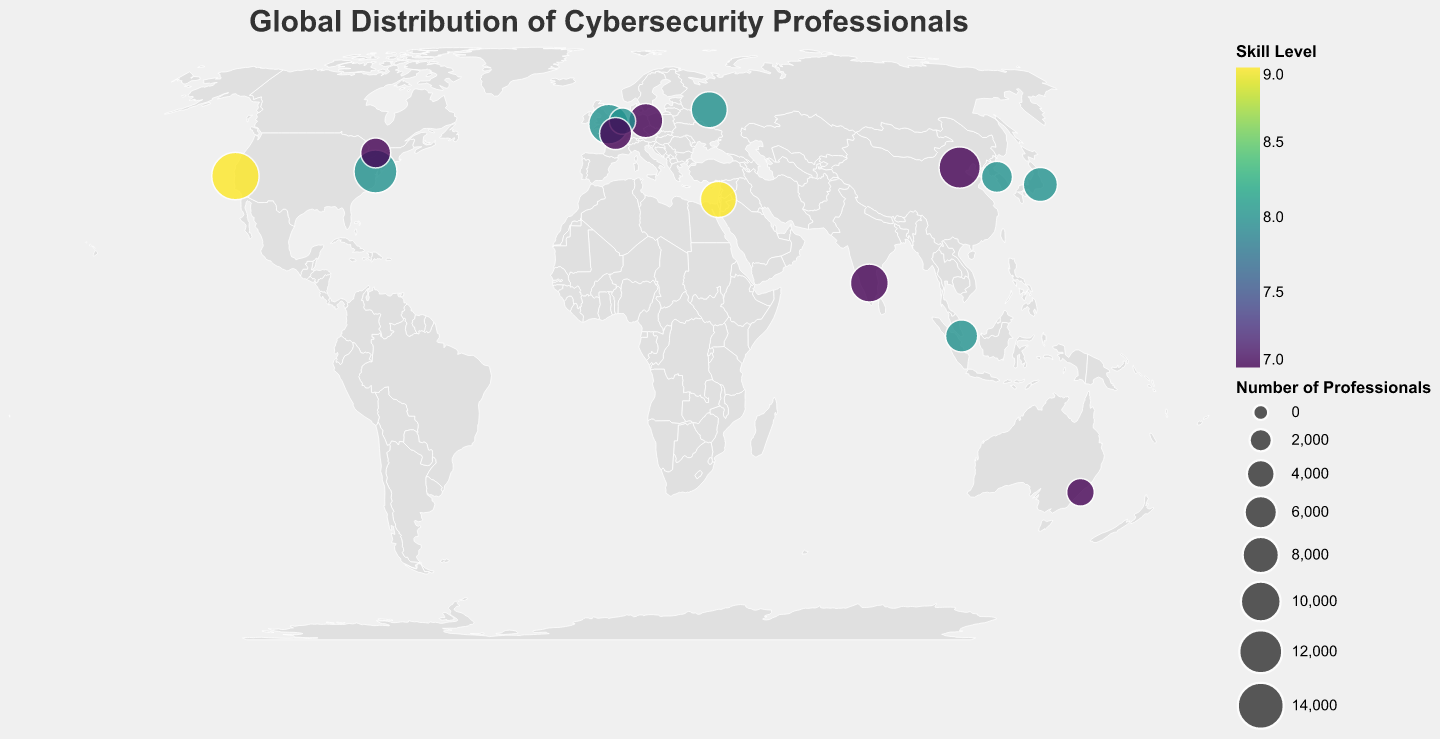What is the title of the plot? The title of the plot is located at the top and is usually a summary of the entire figure. Here, the title is "Global Distribution of Cybersecurity Professionals".
Answer: Global Distribution of Cybersecurity Professionals Which city in the United States has the highest number of cybersecurity professionals? The chart includes data points for San Francisco and Washington D.C. in the United States. By comparing these, San Francisco has 15,000 professionals, which is higher than Washington D.C.'s 12,000 professionals.
Answer: San Francisco Which country has the highest average skill level of cybersecurity professionals? To find this, examine each country's cities and calculate the average skill level: 
- United States: (9+8)/2 = 8.5
- Israel: 9
- United Kingdom: 8
- Singapore: 8
- Germany: 7
- Canada: 7
- India: 7
- Japan: 8
- Australia: 7
- Netherlands: 8
- South Korea: 8
- France: 7
- Russia: 8
- China: 7
Israel has the highest average skill level at 9.
Answer: Israel What is the combined number of cybersecurity professionals in Berlin and Tokyo? The number of professionals in Berlin is 7,000 and in Tokyo is 7,000. Adding these together: 7,000 + 7,000 = 14,000.
Answer: 14,000 Identify the city with the highest skill level and describe its location. The highest skill level shown is 9, and it can be found in both San Francisco (United States) and Tel Aviv (Israel). San Francisco is located at longitude -122.4194 and latitude 37.7749 in the United States. Tel Aviv is located at longitude 34.7818 and latitude 32.0853 in Israel.
Answer: San Francisco and Tel Aviv Which city has more cybersecurity professionals: Beijing or Bangalore? By comparing the data points for the two cities, Beijing has 11,000 professionals and Bangalore has 9,000 professionals. Beijing has more professionals.
Answer: Beijing How does the skill level in Paris compare to the one in Berlin? According to the data, Paris has a skill level of 7 and Berlin has a skill level of 7 as well. Their skill levels are equal.
Answer: Equal What is the color used to represent the highest skill level in the plot? The highest skill level in the dataset is 9, represented by two circles, one for San Francisco and Tel Aviv. According to the legend and color scheme used (viridis), the highest skill level is typically represented by a dark shade of purple.
Answer: Dark purple What is the total number of cybersecurity professionals in Asia according to the plot? Summing the number of professionals from Asian cities:
- Tel Aviv: 8,000
- Singapore: 6,000
- Bangalore: 9,000
- Tokyo: 7,000
- Seoul: 5,500
- Beijing: 11,000
Total: 8,000 + 6,000 + 9,000 + 7,000 + 5,500 + 11,000 = 46,500.
Answer: 46,500 